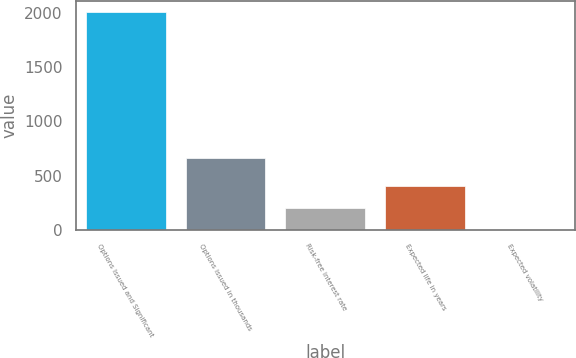Convert chart to OTSL. <chart><loc_0><loc_0><loc_500><loc_500><bar_chart><fcel>Options Issued and Significant<fcel>Options issued in thousands<fcel>Risk-free interest rate<fcel>Expected life in years<fcel>Expected volatility<nl><fcel>2011<fcel>658<fcel>201.44<fcel>402.5<fcel>0.38<nl></chart> 